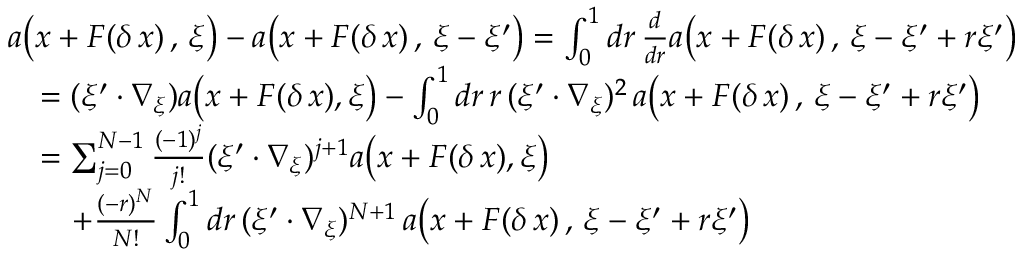Convert formula to latex. <formula><loc_0><loc_0><loc_500><loc_500>\begin{array} { r l } & { a \left ( x + F ( \delta \, x ) \, , \, \xi \right ) - a \left ( x + F ( \delta \, x ) \, , \, \xi - \xi ^ { \prime } \right ) = \int _ { 0 } ^ { 1 } d r \, \frac { d } { d r } a \left ( x + F ( \delta \, x ) \, , \, \xi - \xi ^ { \prime } + r \xi ^ { \prime } \right ) } \\ & { \quad = ( \xi ^ { \prime } \cdot \nabla _ { \xi } ) a \left ( x + F ( \delta \, x ) , \xi \right ) - \int _ { 0 } ^ { 1 } d r \, r \, ( \xi ^ { \prime } \cdot \nabla _ { \xi } ) ^ { 2 } \, a \left ( x + F ( \delta \, x ) \, , \, \xi - \xi ^ { \prime } + r \xi ^ { \prime } \right ) } \\ & { \quad = \sum _ { j = 0 } ^ { N - 1 } \frac { ( - 1 ) ^ { j } } { j ! } ( \xi ^ { \prime } \cdot \nabla _ { \xi } ) ^ { j + 1 } a \left ( x + F ( \delta \, x ) , \xi \right ) } \\ & { \quad + \frac { ( - r ) ^ { N } } { N ! } \int _ { 0 } ^ { 1 } d r \, ( \xi ^ { \prime } \cdot \nabla _ { \xi } ) ^ { N + 1 } \, a \left ( x + F ( \delta \, x ) \, , \, \xi - \xi ^ { \prime } + r \xi ^ { \prime } \right ) } \end{array}</formula> 